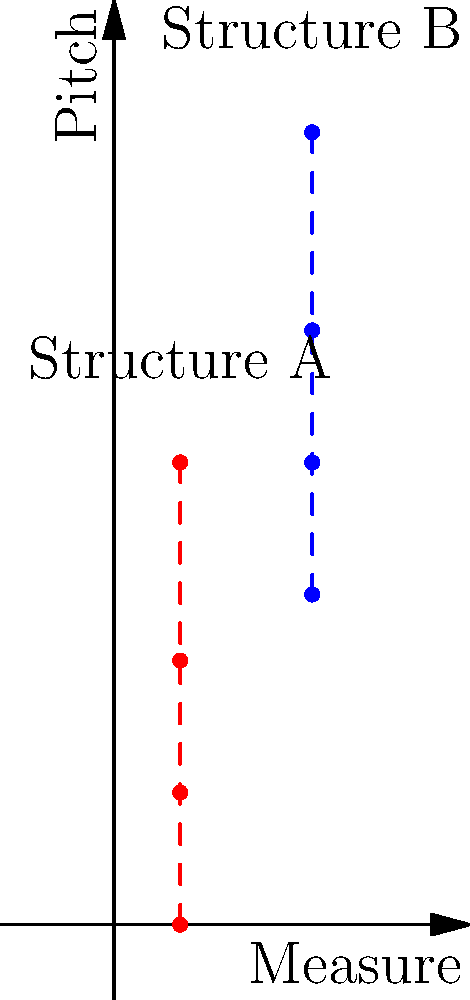In the given diagram representing harmonic structures in a Renaissance motet, Structure A and Structure B appear to be congruent. If Structure A is a root position C major chord, what is the likely identity of Structure B? To solve this problem, we need to follow these steps:

1. Identify Structure A:
   - We're told that Structure A is a root position C major chord.
   - The notes of a C major chord are C (root), E (third), and G (fifth).

2. Analyze the congruence:
   - The diagram shows that Structures A and B have the same shape, indicating they are congruent.
   - This means that the intervallic relationships between the notes are the same in both structures.

3. Determine the transposition:
   - Observe that Structure B is positioned higher on the pitch axis than Structure A.
   - Count the number of semitones between the lowest notes of each structure: from C to F is 5 semitones.

4. Apply the transposition to Structure A:
   - Transposing a C major chord up by 5 semitones results in an F major chord.
   - F major chord consists of F (root), A (third), and C (fifth).

5. Verify the result:
   - An F major chord maintains the same intervallic structure as the C major chord, confirming the congruence.

Therefore, Structure B is likely an F major chord in root position.
Answer: F major chord 